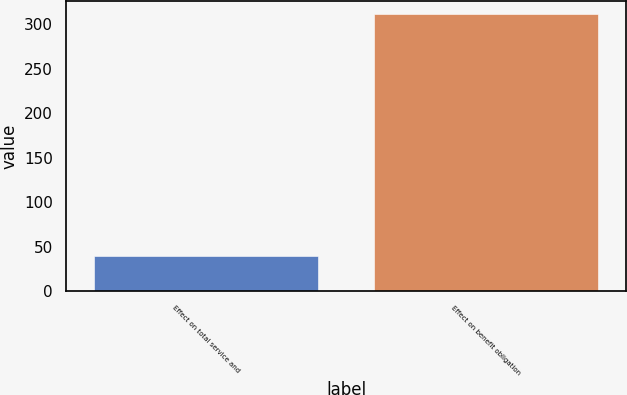Convert chart. <chart><loc_0><loc_0><loc_500><loc_500><bar_chart><fcel>Effect on total service and<fcel>Effect on benefit obligation<nl><fcel>39<fcel>311<nl></chart> 